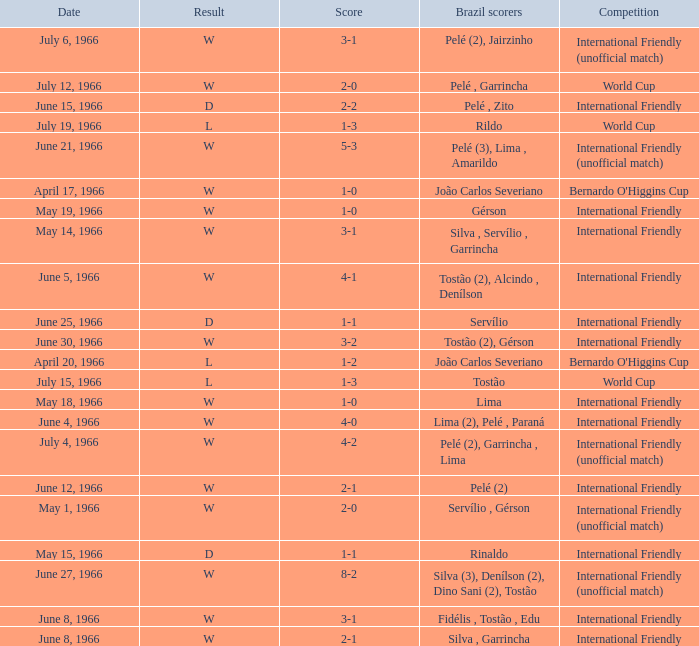What competition has a result of W on June 30, 1966? International Friendly. 